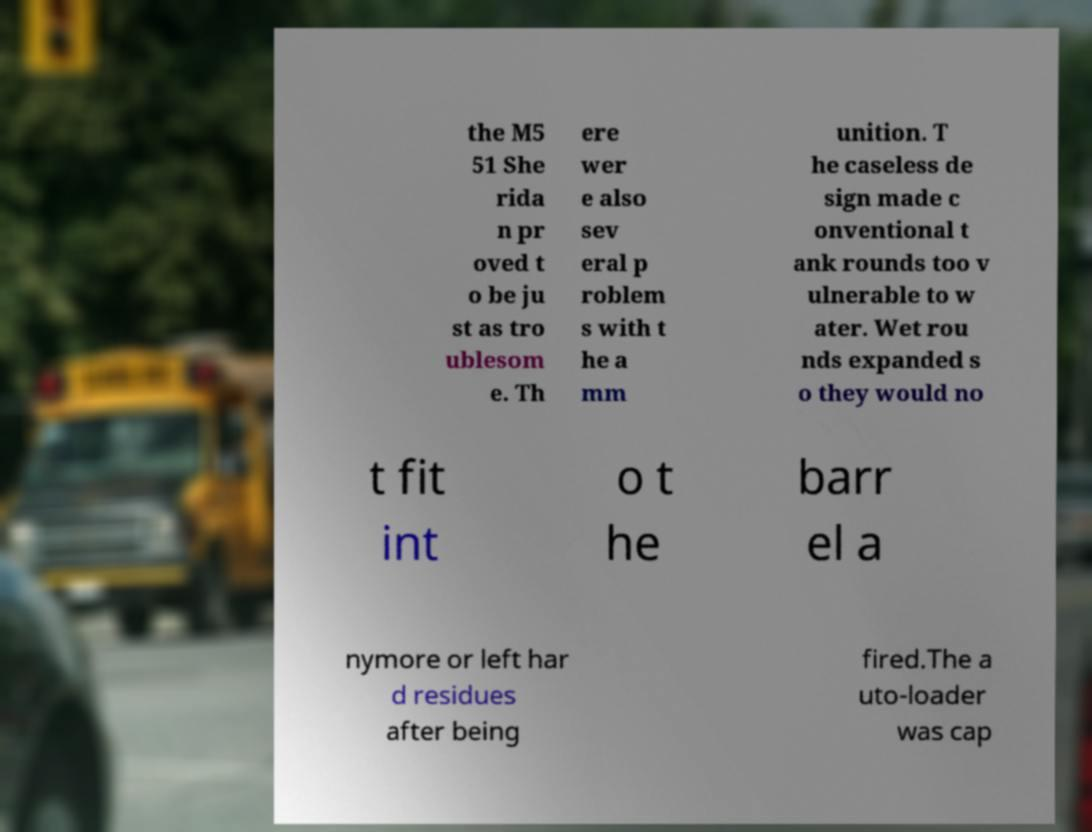What messages or text are displayed in this image? I need them in a readable, typed format. the M5 51 She rida n pr oved t o be ju st as tro ublesom e. Th ere wer e also sev eral p roblem s with t he a mm unition. T he caseless de sign made c onventional t ank rounds too v ulnerable to w ater. Wet rou nds expanded s o they would no t fit int o t he barr el a nymore or left har d residues after being fired.The a uto-loader was cap 